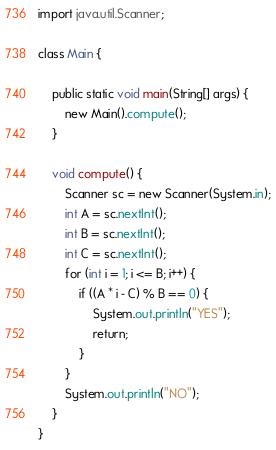<code> <loc_0><loc_0><loc_500><loc_500><_Java_>import java.util.Scanner;

class Main {

    public static void main(String[] args) {
        new Main().compute();
    }

    void compute() {
        Scanner sc = new Scanner(System.in);
        int A = sc.nextInt();
        int B = sc.nextInt();
        int C = sc.nextInt();
        for (int i = 1; i <= B; i++) {
            if ((A * i - C) % B == 0) {
                System.out.println("YES");
                return;
            }
        }
        System.out.println("NO");
    }
}
</code> 